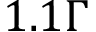Convert formula to latex. <formula><loc_0><loc_0><loc_500><loc_500>1 . 1 \Gamma</formula> 